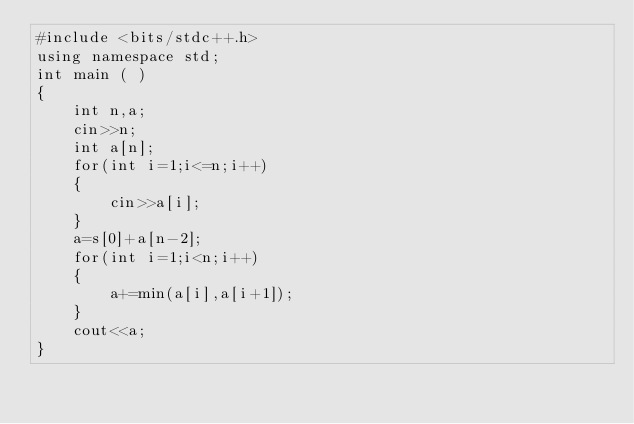<code> <loc_0><loc_0><loc_500><loc_500><_C++_>#include <bits/stdc++.h>
using namespace std;
int main ( )
{
	int n,a;
	cin>>n;
	int a[n];
	for(int i=1;i<=n;i++)
	{
		cin>>a[i];
	}
	a=s[0]+a[n-2];
	for(int i=1;i<n;i++)
	{
		a+=min(a[i],a[i+1]);
	}
	cout<<a;
}</code> 